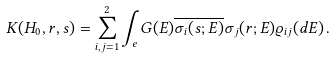Convert formula to latex. <formula><loc_0><loc_0><loc_500><loc_500>K ( H _ { 0 } , r , s ) = \sum _ { i , j = 1 } ^ { 2 } \int _ { e } G ( E ) \overline { \sigma _ { i } ( s ; E ) } \sigma _ { j } ( r ; E ) \varrho _ { i j } ( d E ) \, .</formula> 